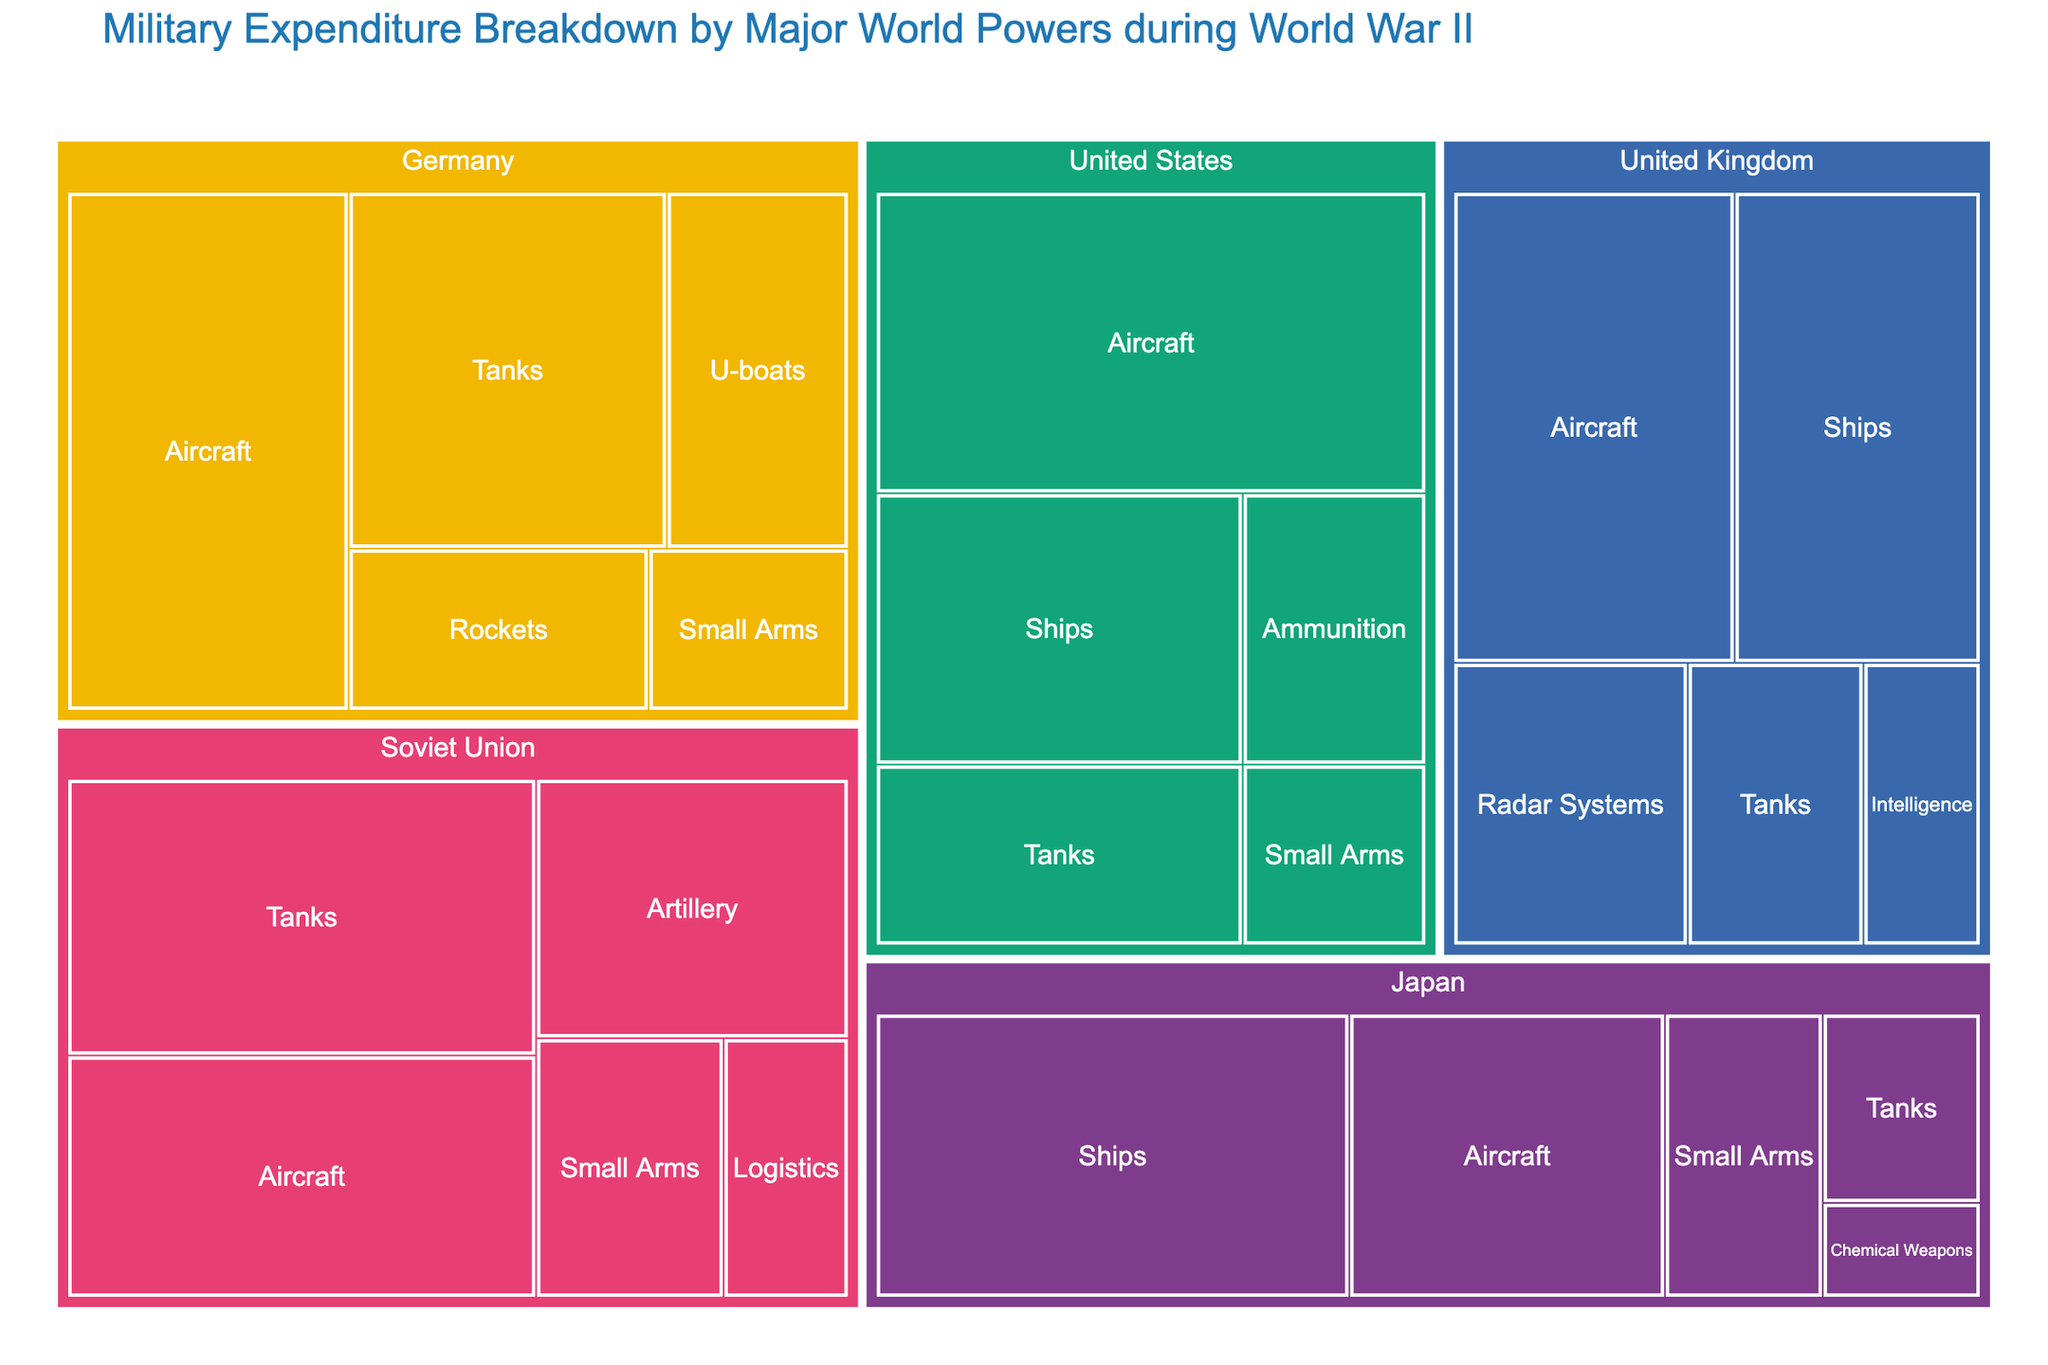What is the title of the treemap? The title of the treemap is displayed at the top of the figure. It provides a summary statement of the data visualized.
Answer: Military Expenditure Breakdown by Major World Powers during World War II Which country has the highest expenditure on aircraft? The treemap visualizes the expenditure by each country in different categories. By looking at the "Aircraft" categories, the country with the largest area for this category indicates the highest expenditure.
Answer: United States What is the total expenditure on tanks by all countries combined? To find the total expenditure on tanks, sum the expenditure values for the "Tanks" category from all the countries. This involves summing 20 (United States) + 40 (Soviet Union) + 35 (Germany) + 15 (United Kingdom) + 10 (Japan).
Answer: 120 Which country has the least expenditure on logistics? In the treemap, look for the "Logistics" expenditure. Only the Soviet Union has this category, making it the lowest expenditure by default.
Answer: Soviet Union How does Germany's expenditure on rockets compare to the United Kingdom's expenditure on radar systems? Compare the expenditure values: Germany's expenditure on rockets is 15 and the United Kingdom's expenditure on radar systems is 20.
Answer: United Kingdom's expenditure on radar systems is higher What is the median military expenditure in the "Small Arms" category across all countries? To find the median expenditure in the "Small Arms" category, list the expenditures: 10 (United States) + 15 (Soviet Union) + 10 (Germany) + 15 (Japan). The sorted values are 10, 10, 15, 15, and the median is the average of the two middle values (10 and 15).
Answer: 12.5 Which category has the highest expenditure for Japan? In the treemap, look at Japan’s categories and find the one with the largest area. The expenditure values indicate that "Ships" has the highest expenditure (45).
Answer: Ships Approximately what proportion of the United States' total expenditure is on aircraft? First, sum up the total expenditure of the United States: 50 (Aircraft) + 30 (Ships) + 20 (Tanks) + 10 (Small Arms) + 15 (Ammunition) = 125. Then, divide the expenditure on aircraft by the total expenditure: 50 / 125 = 0.4 or 40%.
Answer: 40% Which country has a more diversified expenditure between Japan and Germany? Look at the number of different categories Japan and Germany spend on. Japan spends on 5 categories and Germany on 5 categories. Since both countries have the same number of expenditure categories, their diversification can be considered equal.
Answer: Both are equally diversified How much more does the Soviet Union spend on tanks compared to the United Kingdom? The Soviet Union's expenditure on tanks is 40, and the United Kingdom's is 15. Subtract the United Kingdom's expenditure from the Soviet Union’s: 40 - 15 = 25.
Answer: 25 